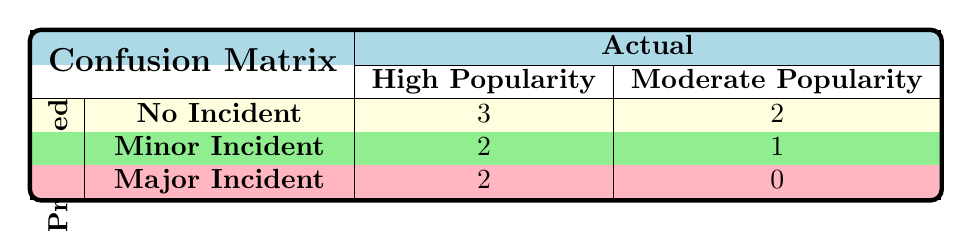What is the total number of roller coasters with a "No Incident"? From the table, we can see that there are 3 roller coasters in the "High Popularity" with "No Incident" and 2 roller coasters in the "Moderate Popularity" with "No Incident". Adding these together gives 3 + 2 = 5.
Answer: 5 How many roller coasters had "Major Incident" with "High Popularity"? Looking at the table, we see that there are 2 roller coasters predicted to have a "Major Incident" under "High Popularity".
Answer: 2 What is the total number of roller coasters categorized as having "Minor Incident"? The table indicates there are 2 roller coasters with "Minor Incident" under "High Popularity" and 1 under "Moderate Popularity". Therefore, the total is 2 + 1 = 3.
Answer: 3 Is there any roller coaster that had a "No Incident" assessed as having "Moderate Popularity"? The table shows 2 roller coasters with "No Incident" classified as "Moderate Popularity". Hence, the answer is yes.
Answer: Yes What percentage of roller coasters predicted to have "No Incident" are actually "High Popularity"? There are a total of 5 roller coasters with "No Incident", of which 3 are classified as "High Popularity". The percentage can be calculated as (3/5) * 100 = 60%.
Answer: 60% What is the average number of incidents per roller coaster for the "High Popularity" group? The "High Popularity" group includes 3 "No Incident", 2 "Minor Incident", and 2 "Major Incident". Therefore, the total is 0 + 1 + 2 = 3 incidents across 7 roller coasters, and the average number of incidents is 3/7, which is approximately 0.43.
Answer: 0.43 Are there more roller coasters with "Moderate Popularity" that had an incident compared to those that had "No Incident"? From the table, there are 3 roller coasters with "Moderate Popularity" (2 "No Incident", 1 "Minor Incident", and 0 "Major Incident"). Since there is only 1 incident recorded, the answer is that there are not more roller coasters with incidents than those with "No Incident".
Answer: No Which category had more roller coasters predicted to have incidents, "Minor Incident" or "Major Incident"? From the table, "Minor Incident" has 3 cases across both popularity categories while "Major Incident" has 2 cases. Therefore, "Minor Incident" is greater than "Major Incident".
Answer: Minor Incident 